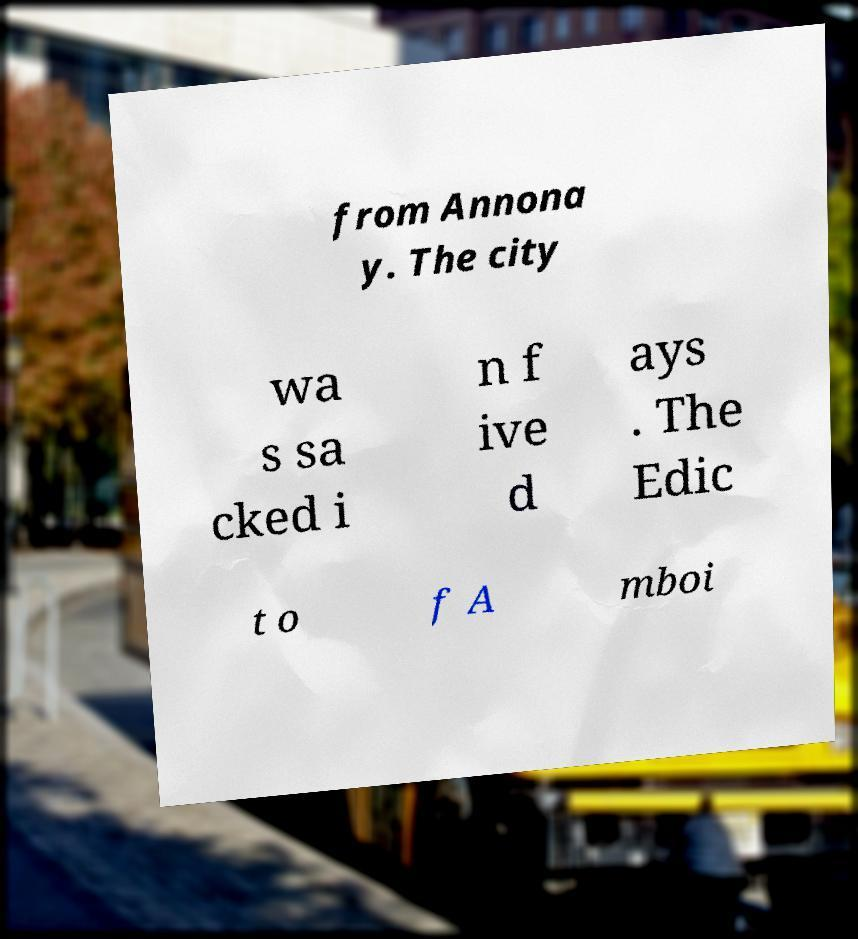Please identify and transcribe the text found in this image. from Annona y. The city wa s sa cked i n f ive d ays . The Edic t o f A mboi 